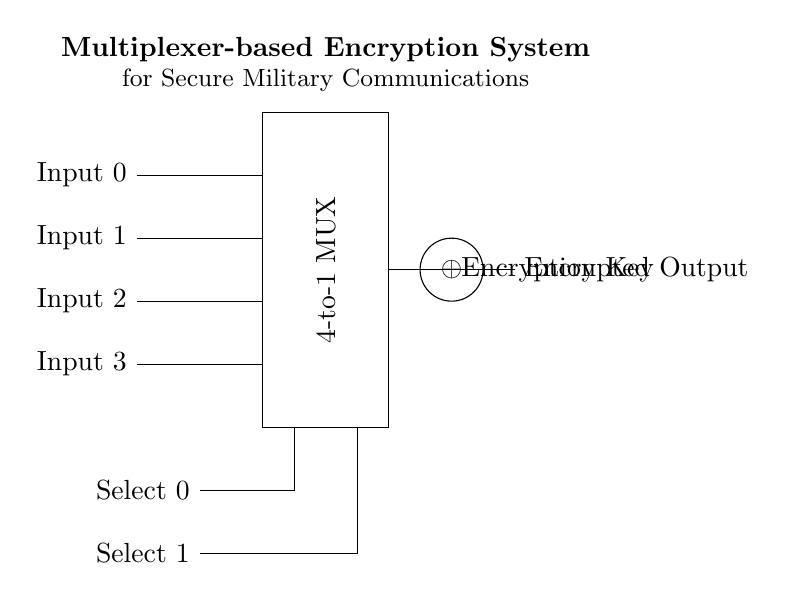What type of multiplexer is shown in the circuit? The circuit diagram depicts a 4-to-1 multiplexer, indicated by the label within the rectangle that describes it. A 4-to-1 multiplexer takes four inputs and channels one to the output based on the select lines.
Answer: 4-to-1 MUX How many inputs does the multiplexer have? The circuit shows four input lines labeled Input 0, Input 1, Input 2, and Input 3. This indicates that the multiplexer is designed to handle four separate input signals.
Answer: Four What is the purpose of the XOR gate in the circuit? The XOR gate is used to combine the output of the multiplexer with the encryption key. The function it performs is to encrypt the chosen input signal, ensuring secure communication by altering the output based on the key input.
Answer: Encryption How many select lines are indicated in the circuit? There are two select lines in the circuit, labeled Select 0 and Select 1, which are needed to choose one out of the four input signals for the multiplexer to forward to the output.
Answer: Two What is the significance of the encryption key in this circuit? The encryption key is significant because it provides the means to secure the data being transmitted by modifying the output of the multiplexer. This ensures that even if the data is intercepted, it cannot be easily understood without the key.
Answer: Security What is the output of the circuit labeled as? The output of the circuit is labeled as "Encrypted Output," indicating that it is the result after the multiplexer and XOR operation, signifying that the transmitted data is altered and secured.
Answer: Encrypted Output 